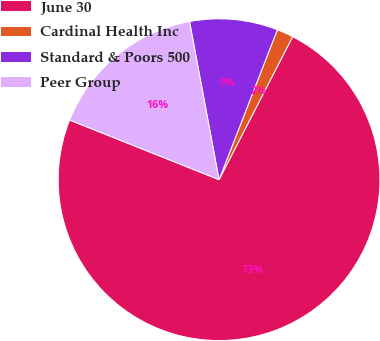Convert chart to OTSL. <chart><loc_0><loc_0><loc_500><loc_500><pie_chart><fcel>June 30<fcel>Cardinal Health Inc<fcel>Standard & Poors 500<fcel>Peer Group<nl><fcel>73.48%<fcel>1.66%<fcel>8.84%<fcel>16.02%<nl></chart> 